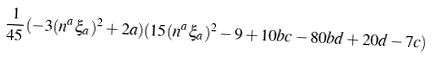<formula> <loc_0><loc_0><loc_500><loc_500>\frac { 1 } { 4 5 } ( - 3 ( n ^ { a } \xi _ { a } ) ^ { 2 } + 2 a ) ( 1 5 ( n ^ { a } \xi _ { a } ) ^ { 2 } - 9 + 1 0 b c - 8 0 b d + 2 0 d - 7 c )</formula> 